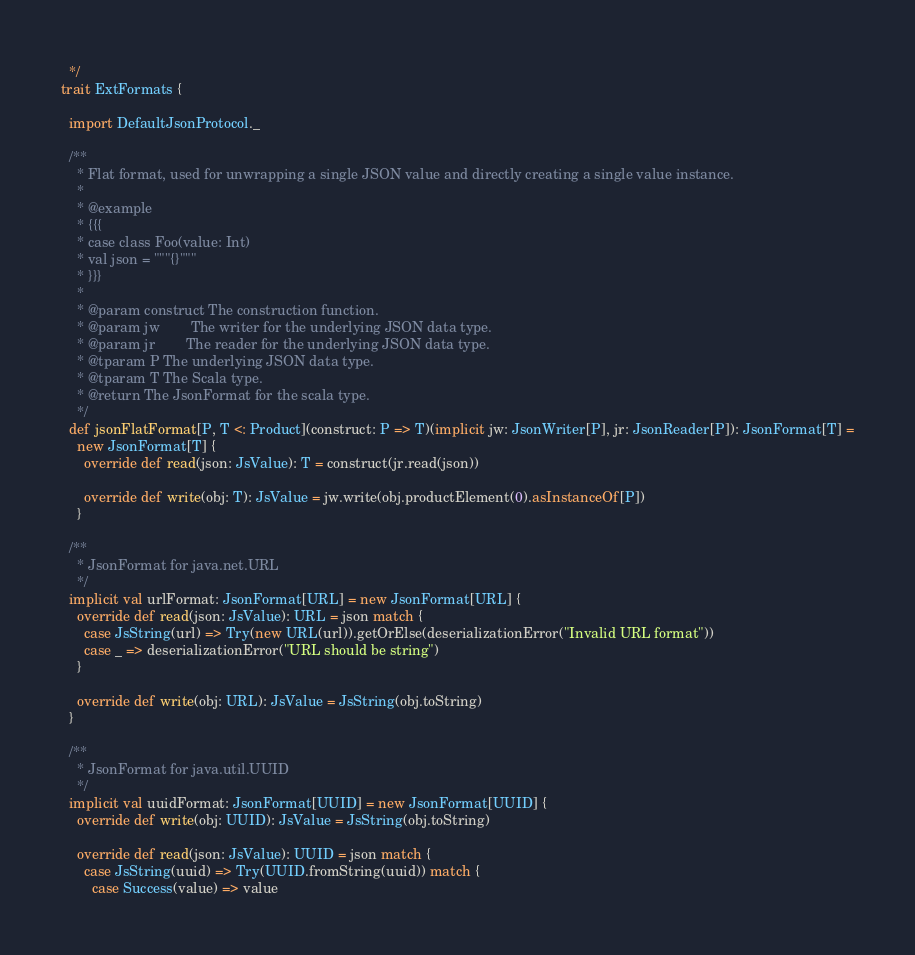Convert code to text. <code><loc_0><loc_0><loc_500><loc_500><_Scala_>  */
trait ExtFormats {

  import DefaultJsonProtocol._

  /**
    * Flat format, used for unwrapping a single JSON value and directly creating a single value instance.
    *
    * @example
    * {{{
    * case class Foo(value: Int)
    * val json = """{}"""
    * }}}
    *
    * @param construct The construction function.
    * @param jw        The writer for the underlying JSON data type.
    * @param jr        The reader for the underlying JSON data type.
    * @tparam P The underlying JSON data type.
    * @tparam T The Scala type.
    * @return The JsonFormat for the scala type.
    */
  def jsonFlatFormat[P, T <: Product](construct: P => T)(implicit jw: JsonWriter[P], jr: JsonReader[P]): JsonFormat[T] =
    new JsonFormat[T] {
      override def read(json: JsValue): T = construct(jr.read(json))

      override def write(obj: T): JsValue = jw.write(obj.productElement(0).asInstanceOf[P])
    }

  /**
    * JsonFormat for java.net.URL
    */
  implicit val urlFormat: JsonFormat[URL] = new JsonFormat[URL] {
    override def read(json: JsValue): URL = json match {
      case JsString(url) => Try(new URL(url)).getOrElse(deserializationError("Invalid URL format"))
      case _ => deserializationError("URL should be string")
    }

    override def write(obj: URL): JsValue = JsString(obj.toString)
  }

  /**
    * JsonFormat for java.util.UUID
    */
  implicit val uuidFormat: JsonFormat[UUID] = new JsonFormat[UUID] {
    override def write(obj: UUID): JsValue = JsString(obj.toString)

    override def read(json: JsValue): UUID = json match {
      case JsString(uuid) => Try(UUID.fromString(uuid)) match {
        case Success(value) => value</code> 